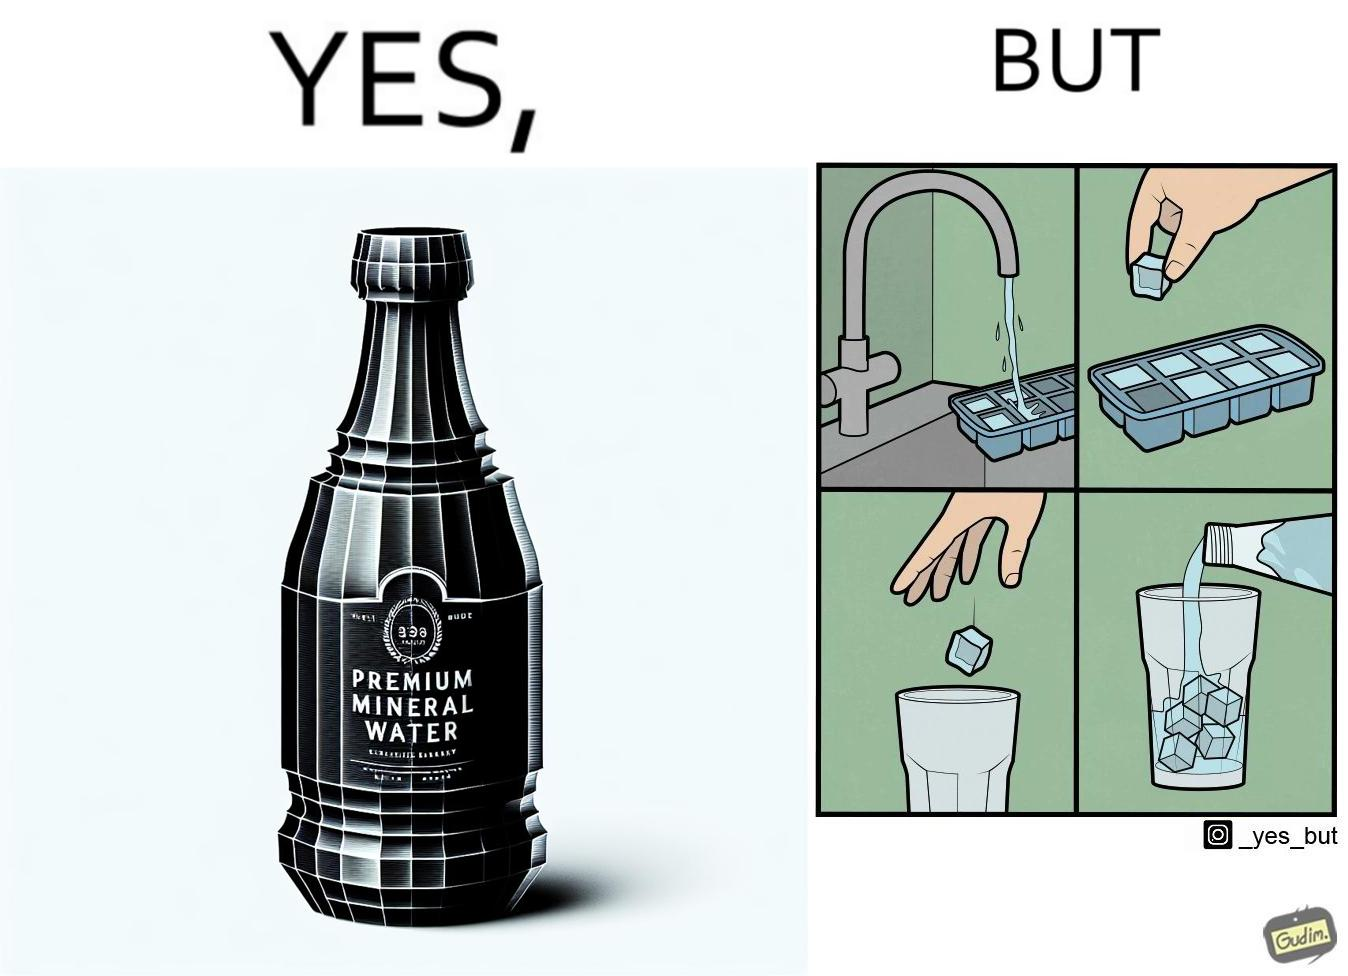Is this image satirical or non-satirical? Yes, this image is satirical. 